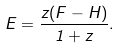Convert formula to latex. <formula><loc_0><loc_0><loc_500><loc_500>E = \frac { z ( F - H ) } { 1 + z } .</formula> 